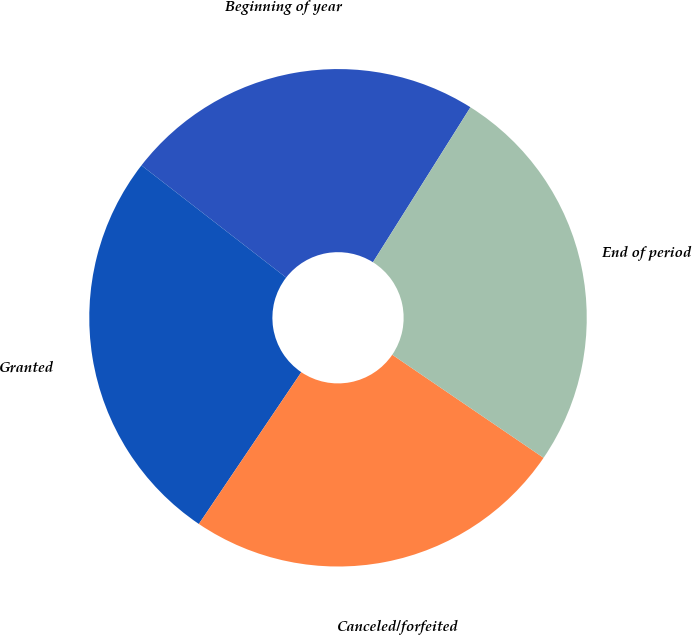<chart> <loc_0><loc_0><loc_500><loc_500><pie_chart><fcel>Beginning of year<fcel>Granted<fcel>Canceled/forfeited<fcel>End of period<nl><fcel>23.44%<fcel>26.05%<fcel>24.93%<fcel>25.58%<nl></chart> 